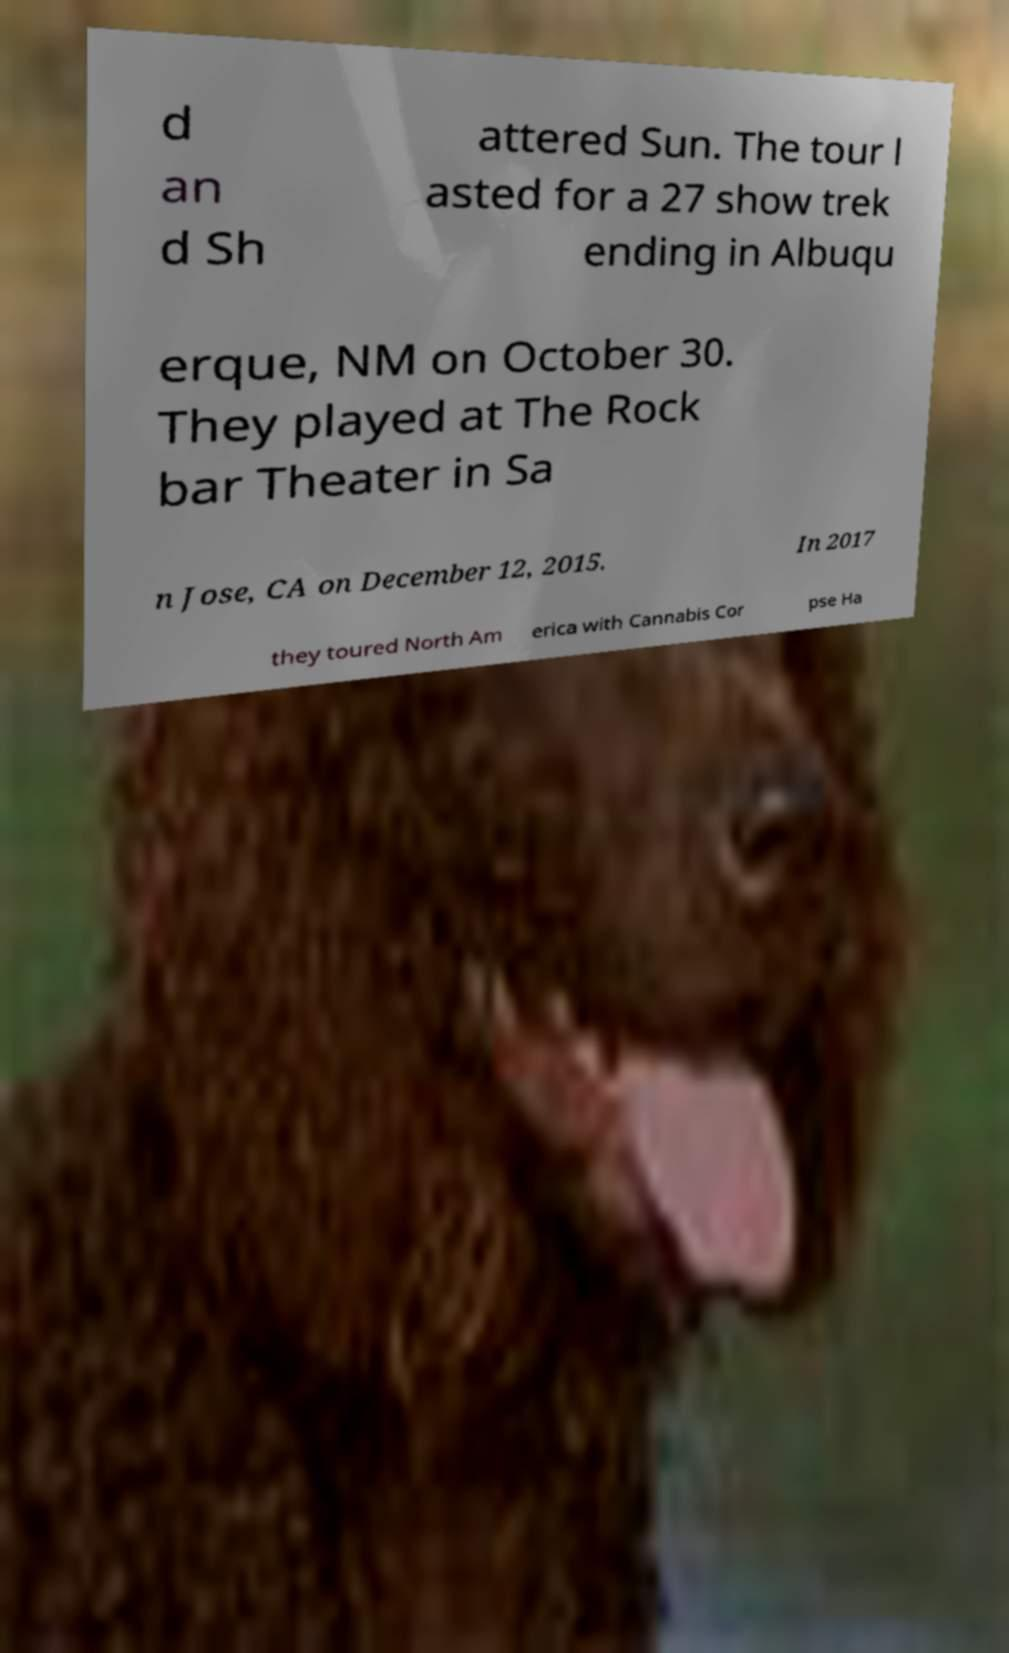Please read and relay the text visible in this image. What does it say? d an d Sh attered Sun. The tour l asted for a 27 show trek ending in Albuqu erque, NM on October 30. They played at The Rock bar Theater in Sa n Jose, CA on December 12, 2015. In 2017 they toured North Am erica with Cannabis Cor pse Ha 